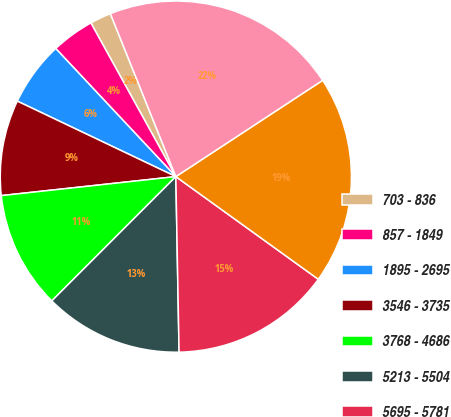<chart> <loc_0><loc_0><loc_500><loc_500><pie_chart><fcel>703 - 836<fcel>857 - 1849<fcel>1895 - 2695<fcel>3546 - 3735<fcel>3768 - 4686<fcel>5213 - 5504<fcel>5695 - 5781<fcel>7615 - 8361<fcel>8819 - 9411<nl><fcel>1.96%<fcel>3.95%<fcel>5.94%<fcel>8.8%<fcel>10.79%<fcel>12.78%<fcel>14.77%<fcel>19.18%<fcel>21.84%<nl></chart> 